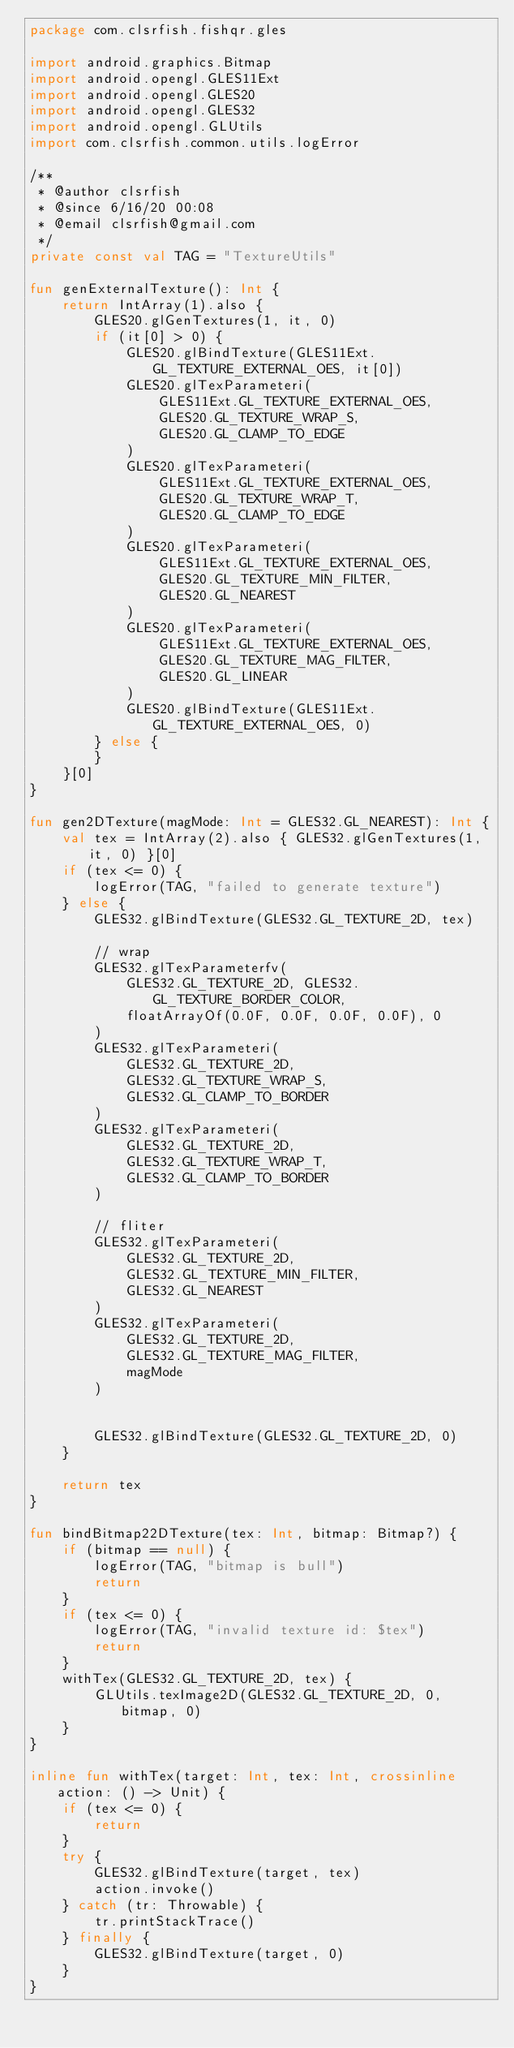Convert code to text. <code><loc_0><loc_0><loc_500><loc_500><_Kotlin_>package com.clsrfish.fishqr.gles

import android.graphics.Bitmap
import android.opengl.GLES11Ext
import android.opengl.GLES20
import android.opengl.GLES32
import android.opengl.GLUtils
import com.clsrfish.common.utils.logError

/**
 * @author clsrfish
 * @since 6/16/20 00:08
 * @email clsrfish@gmail.com
 */
private const val TAG = "TextureUtils"

fun genExternalTexture(): Int {
    return IntArray(1).also {
        GLES20.glGenTextures(1, it, 0)
        if (it[0] > 0) {
            GLES20.glBindTexture(GLES11Ext.GL_TEXTURE_EXTERNAL_OES, it[0])
            GLES20.glTexParameteri(
                GLES11Ext.GL_TEXTURE_EXTERNAL_OES,
                GLES20.GL_TEXTURE_WRAP_S,
                GLES20.GL_CLAMP_TO_EDGE
            )
            GLES20.glTexParameteri(
                GLES11Ext.GL_TEXTURE_EXTERNAL_OES,
                GLES20.GL_TEXTURE_WRAP_T,
                GLES20.GL_CLAMP_TO_EDGE
            )
            GLES20.glTexParameteri(
                GLES11Ext.GL_TEXTURE_EXTERNAL_OES,
                GLES20.GL_TEXTURE_MIN_FILTER,
                GLES20.GL_NEAREST
            )
            GLES20.glTexParameteri(
                GLES11Ext.GL_TEXTURE_EXTERNAL_OES,
                GLES20.GL_TEXTURE_MAG_FILTER,
                GLES20.GL_LINEAR
            )
            GLES20.glBindTexture(GLES11Ext.GL_TEXTURE_EXTERNAL_OES, 0)
        } else {
        }
    }[0]
}

fun gen2DTexture(magMode: Int = GLES32.GL_NEAREST): Int {
    val tex = IntArray(2).also { GLES32.glGenTextures(1, it, 0) }[0]
    if (tex <= 0) {
        logError(TAG, "failed to generate texture")
    } else {
        GLES32.glBindTexture(GLES32.GL_TEXTURE_2D, tex)

        // wrap
        GLES32.glTexParameterfv(
            GLES32.GL_TEXTURE_2D, GLES32.GL_TEXTURE_BORDER_COLOR,
            floatArrayOf(0.0F, 0.0F, 0.0F, 0.0F), 0
        )
        GLES32.glTexParameteri(
            GLES32.GL_TEXTURE_2D,
            GLES32.GL_TEXTURE_WRAP_S,
            GLES32.GL_CLAMP_TO_BORDER
        )
        GLES32.glTexParameteri(
            GLES32.GL_TEXTURE_2D,
            GLES32.GL_TEXTURE_WRAP_T,
            GLES32.GL_CLAMP_TO_BORDER
        )

        // fliter
        GLES32.glTexParameteri(
            GLES32.GL_TEXTURE_2D,
            GLES32.GL_TEXTURE_MIN_FILTER,
            GLES32.GL_NEAREST
        )
        GLES32.glTexParameteri(
            GLES32.GL_TEXTURE_2D,
            GLES32.GL_TEXTURE_MAG_FILTER,
            magMode
        )


        GLES32.glBindTexture(GLES32.GL_TEXTURE_2D, 0)
    }

    return tex
}

fun bindBitmap22DTexture(tex: Int, bitmap: Bitmap?) {
    if (bitmap == null) {
        logError(TAG, "bitmap is bull")
        return
    }
    if (tex <= 0) {
        logError(TAG, "invalid texture id: $tex")
        return
    }
    withTex(GLES32.GL_TEXTURE_2D, tex) {
        GLUtils.texImage2D(GLES32.GL_TEXTURE_2D, 0, bitmap, 0)
    }
}

inline fun withTex(target: Int, tex: Int, crossinline action: () -> Unit) {
    if (tex <= 0) {
        return
    }
    try {
        GLES32.glBindTexture(target, tex)
        action.invoke()
    } catch (tr: Throwable) {
        tr.printStackTrace()
    } finally {
        GLES32.glBindTexture(target, 0)
    }
}</code> 